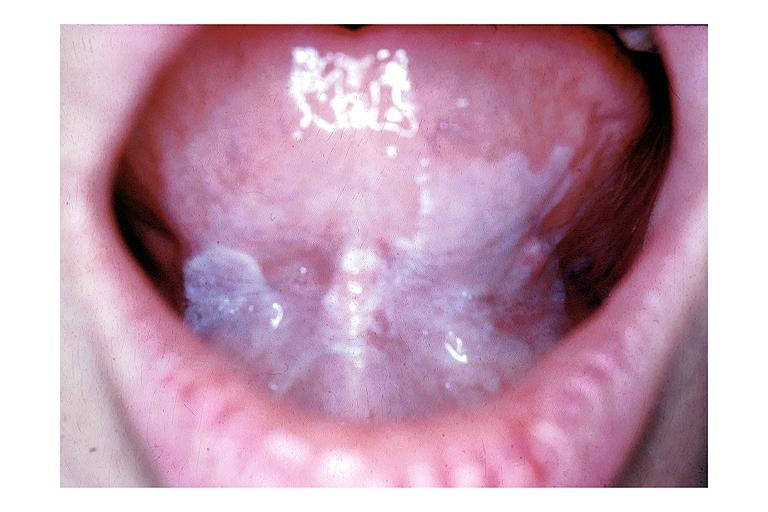s di george syndrome present?
Answer the question using a single word or phrase. No 